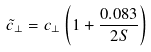Convert formula to latex. <formula><loc_0><loc_0><loc_500><loc_500>\tilde { c } _ { \perp } = c _ { \perp } \left ( 1 + \frac { 0 . 0 8 3 } { 2 S } \right )</formula> 